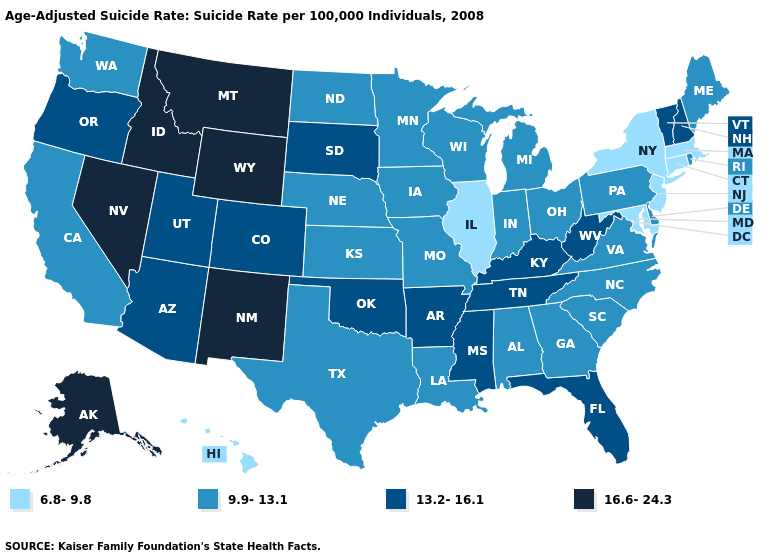Is the legend a continuous bar?
Be succinct. No. What is the highest value in the USA?
Answer briefly. 16.6-24.3. Is the legend a continuous bar?
Short answer required. No. How many symbols are there in the legend?
Give a very brief answer. 4. Name the states that have a value in the range 6.8-9.8?
Give a very brief answer. Connecticut, Hawaii, Illinois, Maryland, Massachusetts, New Jersey, New York. Does Connecticut have the lowest value in the USA?
Write a very short answer. Yes. Name the states that have a value in the range 6.8-9.8?
Answer briefly. Connecticut, Hawaii, Illinois, Maryland, Massachusetts, New Jersey, New York. Does Indiana have the lowest value in the MidWest?
Keep it brief. No. What is the lowest value in states that border Oklahoma?
Answer briefly. 9.9-13.1. What is the value of Maine?
Keep it brief. 9.9-13.1. What is the value of Indiana?
Write a very short answer. 9.9-13.1. What is the highest value in states that border Colorado?
Quick response, please. 16.6-24.3. Name the states that have a value in the range 6.8-9.8?
Answer briefly. Connecticut, Hawaii, Illinois, Maryland, Massachusetts, New Jersey, New York. Does the map have missing data?
Write a very short answer. No. Name the states that have a value in the range 9.9-13.1?
Be succinct. Alabama, California, Delaware, Georgia, Indiana, Iowa, Kansas, Louisiana, Maine, Michigan, Minnesota, Missouri, Nebraska, North Carolina, North Dakota, Ohio, Pennsylvania, Rhode Island, South Carolina, Texas, Virginia, Washington, Wisconsin. 